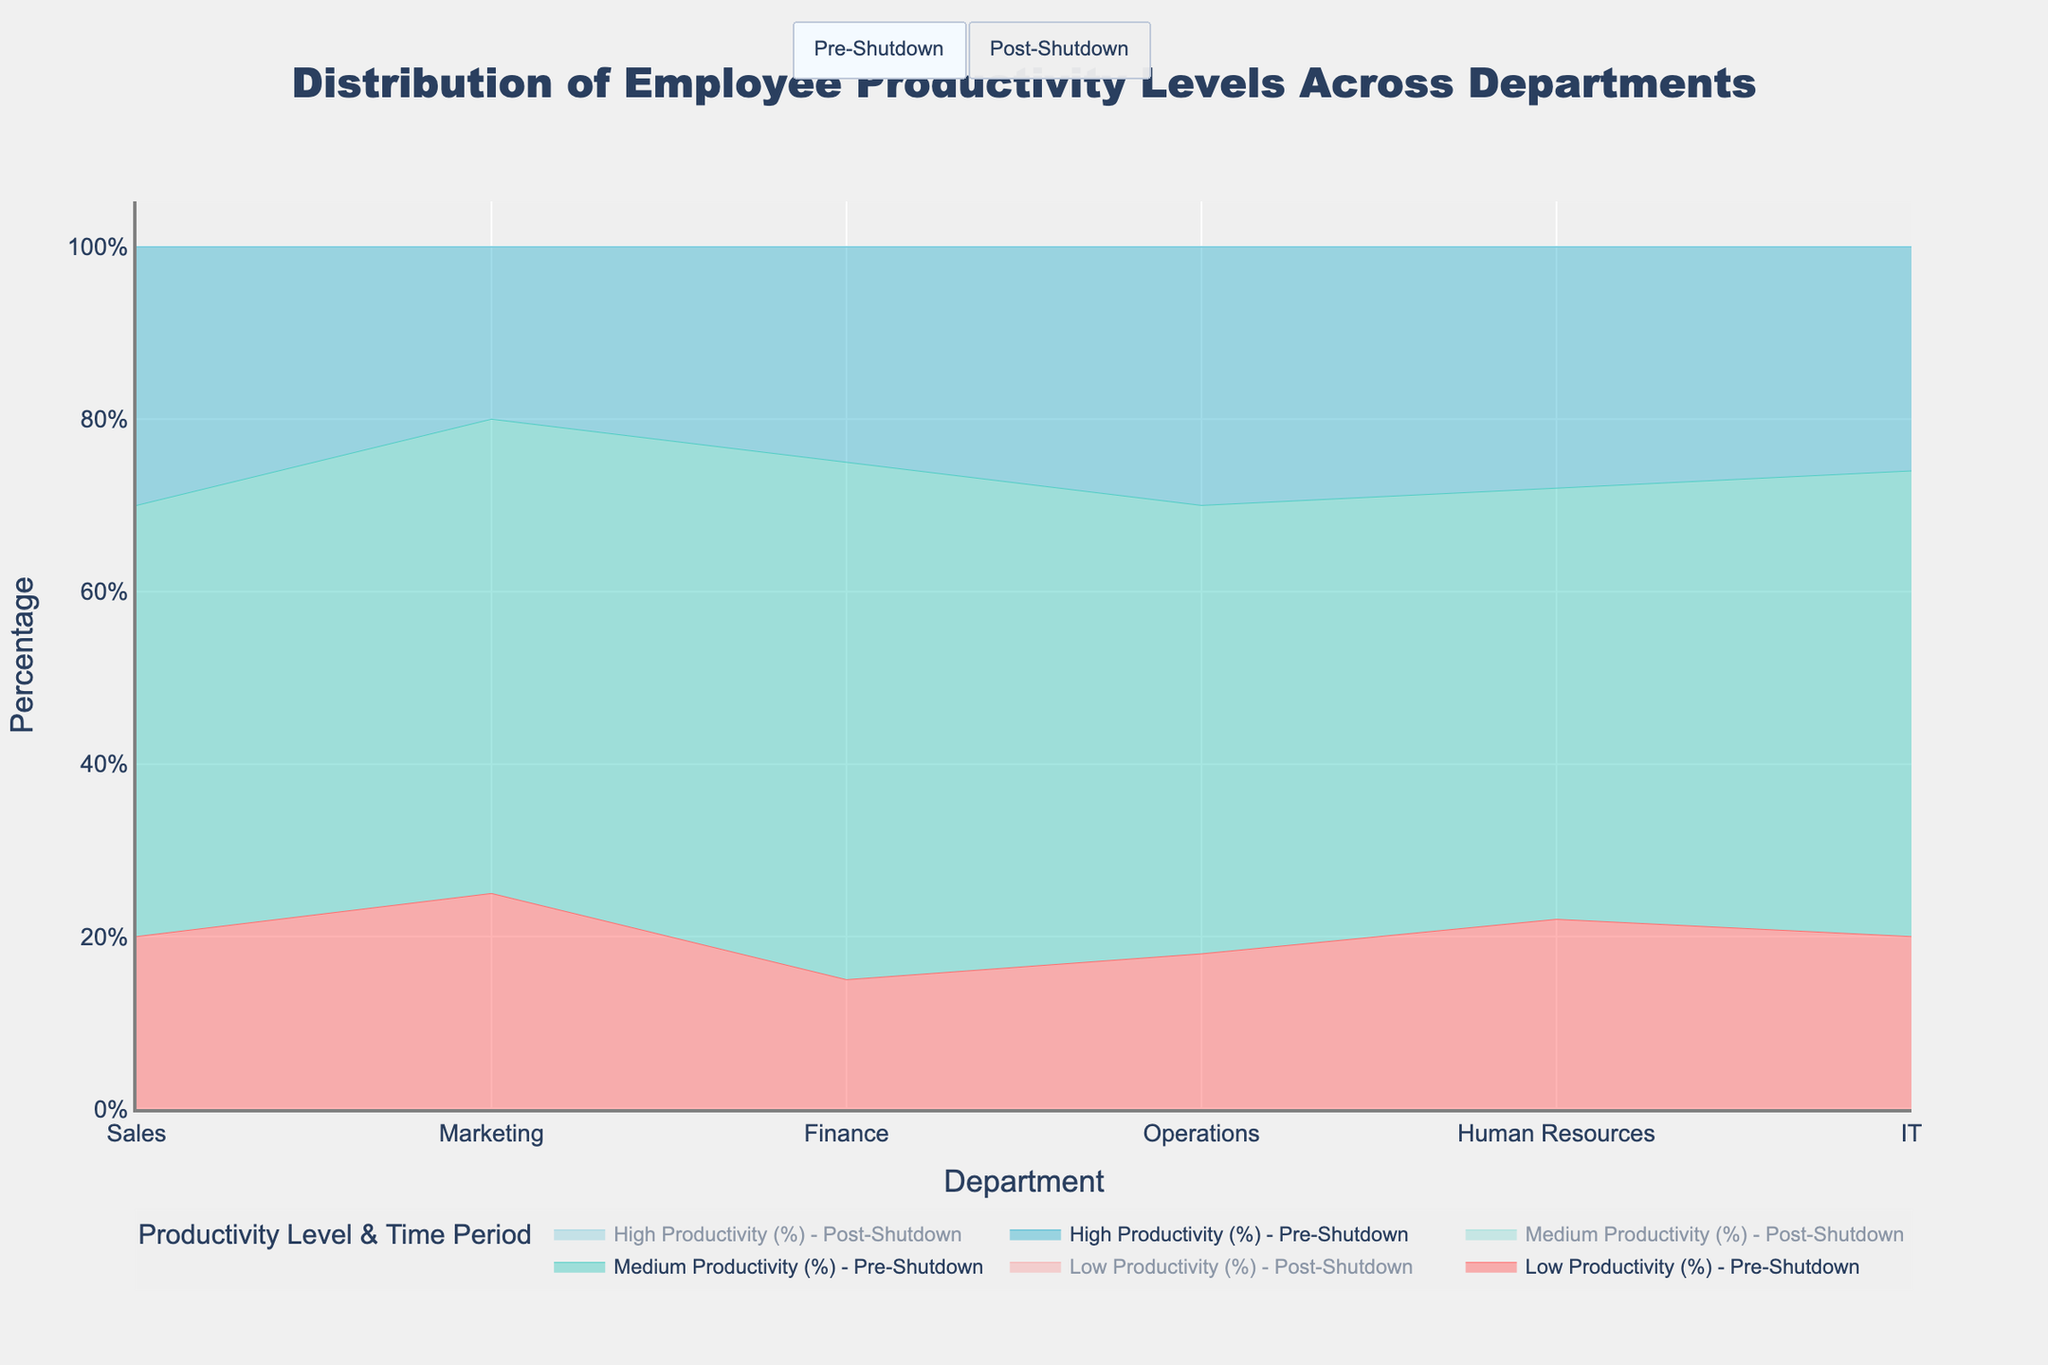What is the title of the chart? The title is usually placed at the top center of the chart. In this case, the title describes the distribution of employee productivity levels across different departments.
Answer: Distribution of Employee Productivity Levels Across Departments Which department had the highest proportion of employees with high productivity in the pre-shutdown period? To find this, look at the "High Productivity (%)" line for the pre-shutdown period for all departments and determine which one is highest. From the data, Operations and Sales each have 30%.
Answer: Operations and Sales How did the percentage of employees with low productivity in the Sales department change from pre- to post-shutdown? First, find the percentage of low productivity employees in Sales pre-shutdown (20%). Then find the same value post-shutdown (30%). Subtract the pre-shutdown value from the post-shutdown value to see the change (30% - 20%).
Answer: Increased by 10% Which department had the smallest change in the percentage of high productivity employees from pre- to post-shutdown? Calculate the difference in "High Productivity (%)" between pre- and post-shutdown for each department. Compare these differences to identify the smallest one. IT had a change of 1% (26% to 25%).
Answer: IT Did the Operations department see an increase or decrease in the percentage of medium productivity employees post-shutdown? Look at the medium productivity percentage for Operations pre-shutdown (52%) and compare it to the post-shutdown percentage (50%). Since 52% > 50%, it represents a decrease.
Answer: Decrease Compare the changes in high productivity percentages between IT and Human Resources from pre- to post-shutdown. Which department saw a larger decrease? For IT, high productivity changed from 26% pre-shutdown to 25% post-shutdown (a decrease of 1%). For Human Resources, it changed from 28% to 20% (a decrease of 8%). Therefore, Human Resources had a larger decrease.
Answer: Human Resources What is the total percentage of employees with medium productivity across all departments in the pre-shutdown period? Sum the medium productivity percentages for all departments during pre-shutdown: Sales (50%), Marketing (55%), Finance (60%), Operations (52%), Human Resources (50%), and IT (54%). This totals to 321%. Divide by the number of departments (6) to get the average. (50 + 55 + 60 + 52 + 50 + 54 = 321)
Answer: 321% If you compare the pre- and post-shutdown periods, which productivity level had the most consistent distribution across all departments? Look at the changes in the percentages for low, medium, and high productivity across all departments between the periods. The sums of individual departments' changes for each productivity level show that medium productivity varies the least.
Answer: Medium Productivity Which department experienced the largest increase in low productivity employees from pre- to post-shutdown? Calculate the difference in low productivity percentages between pre- and post-shutdown for each department and identify the largest increase. Marketing had the largest increase from 25% to 35% (10%).
Answer: Marketing 